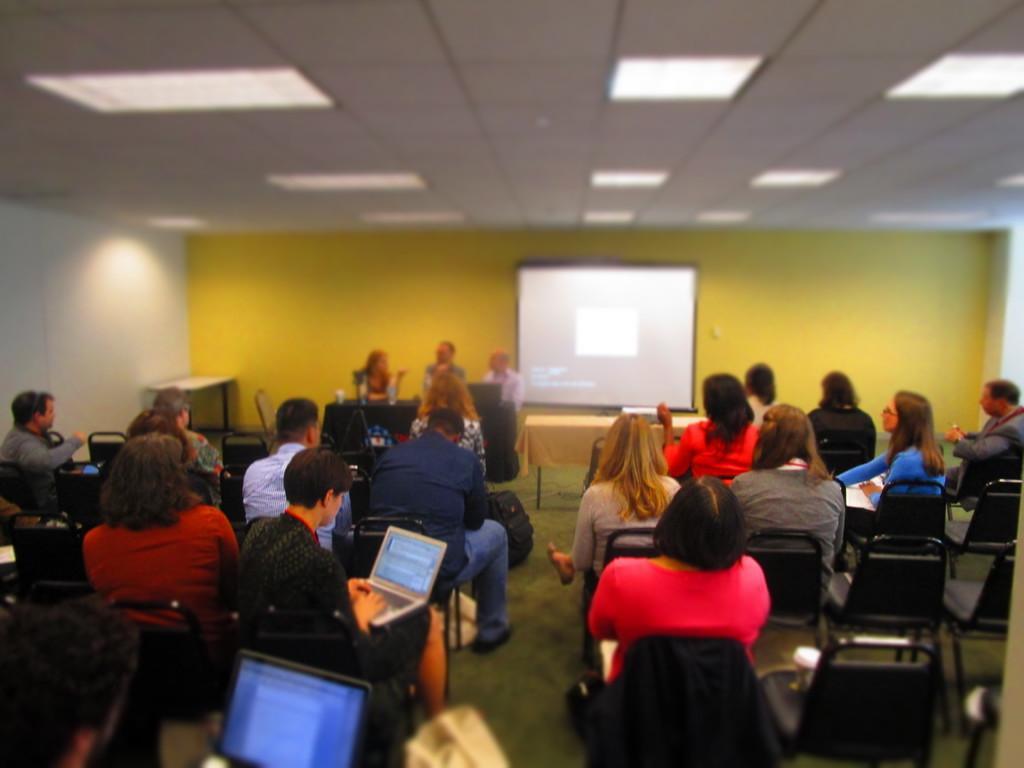Describe this image in one or two sentences. In the image there are many people sitting on the chairs. There are few people holding laptops. In front of them there is a table. Behind the table there are three persons sitting. Behind them there is screen. At the top of the image there is ceiling with lights. 